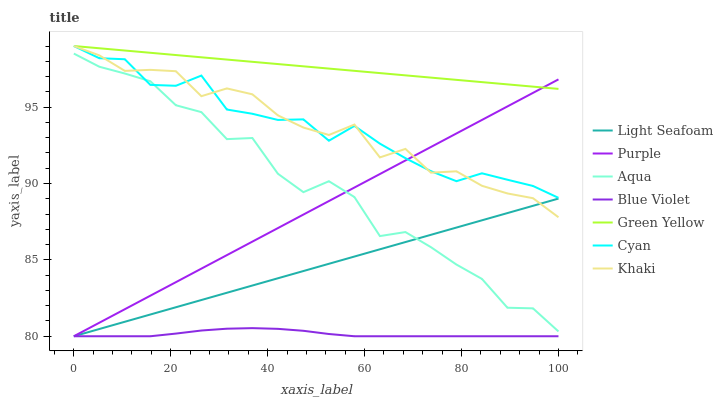Does Blue Violet have the minimum area under the curve?
Answer yes or no. Yes. Does Green Yellow have the maximum area under the curve?
Answer yes or no. Yes. Does Purple have the minimum area under the curve?
Answer yes or no. No. Does Purple have the maximum area under the curve?
Answer yes or no. No. Is Green Yellow the smoothest?
Answer yes or no. Yes. Is Aqua the roughest?
Answer yes or no. Yes. Is Purple the smoothest?
Answer yes or no. No. Is Purple the roughest?
Answer yes or no. No. Does Light Seafoam have the lowest value?
Answer yes or no. Yes. Does Aqua have the lowest value?
Answer yes or no. No. Does Green Yellow have the highest value?
Answer yes or no. Yes. Does Purple have the highest value?
Answer yes or no. No. Is Aqua less than Green Yellow?
Answer yes or no. Yes. Is Khaki greater than Blue Violet?
Answer yes or no. Yes. Does Khaki intersect Light Seafoam?
Answer yes or no. Yes. Is Khaki less than Light Seafoam?
Answer yes or no. No. Is Khaki greater than Light Seafoam?
Answer yes or no. No. Does Aqua intersect Green Yellow?
Answer yes or no. No. 